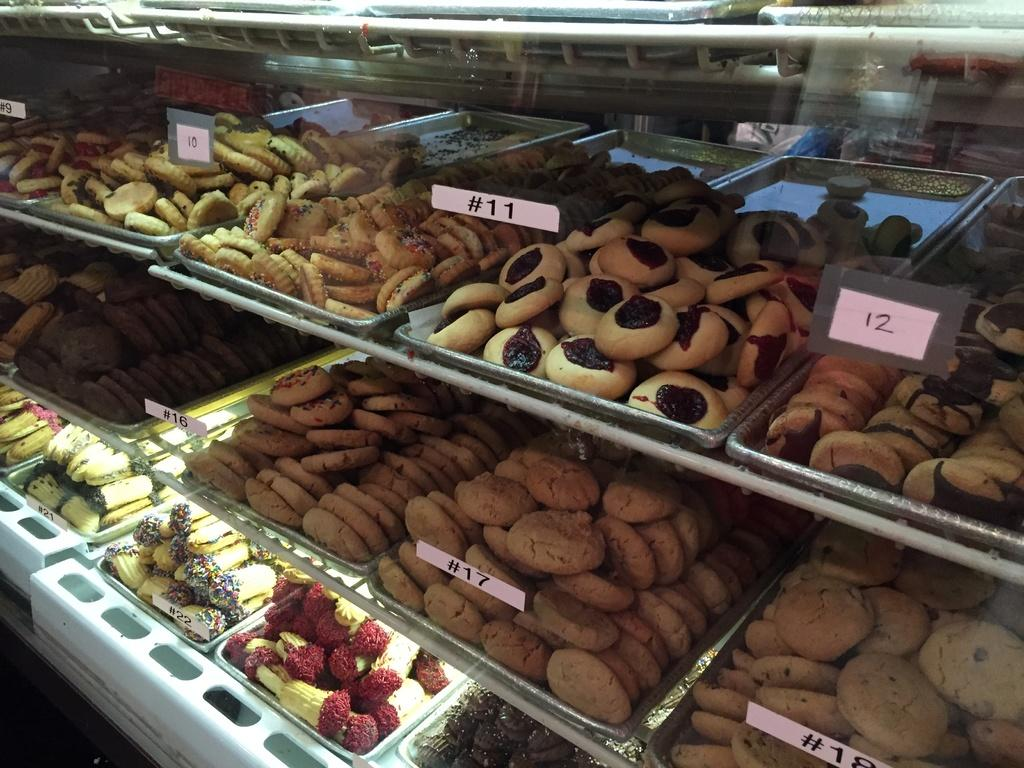What is on the racks in the image? There are trays on racks in the image. What can be found on the trays? There are snacks on the trays. What additional items are visible in the image? There are tags in the image. What type of oil can be seen dripping from the trays in the image? There is no oil present in the image; it features trays with snacks and tags. 